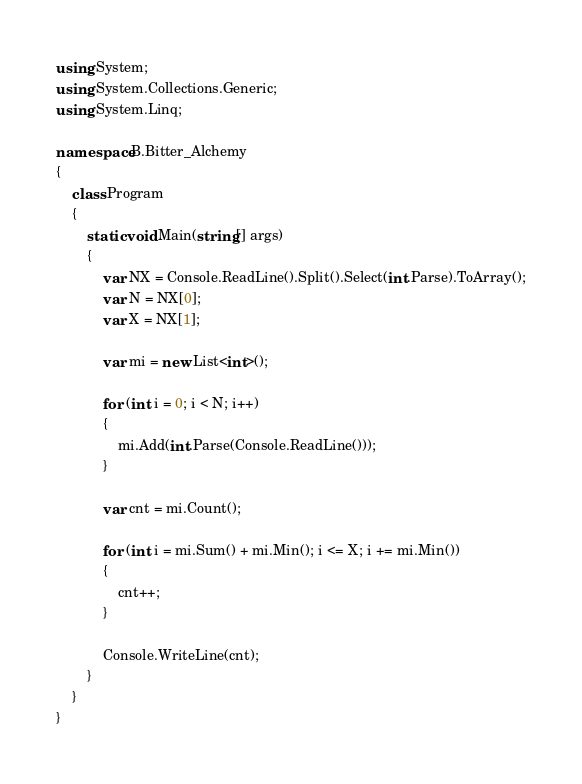Convert code to text. <code><loc_0><loc_0><loc_500><loc_500><_C#_>using System;
using System.Collections.Generic;
using System.Linq;

namespace B.Bitter_Alchemy
{
    class Program
    {
        static void Main(string[] args)
        {
            var NX = Console.ReadLine().Split().Select(int.Parse).ToArray();
            var N = NX[0];
            var X = NX[1];

            var mi = new List<int>();

            for (int i = 0; i < N; i++)
            {
                mi.Add(int.Parse(Console.ReadLine()));
            }

            var cnt = mi.Count();

            for (int i = mi.Sum() + mi.Min(); i <= X; i += mi.Min())
            {
                cnt++;
            }

            Console.WriteLine(cnt);
        }
    }
}
</code> 